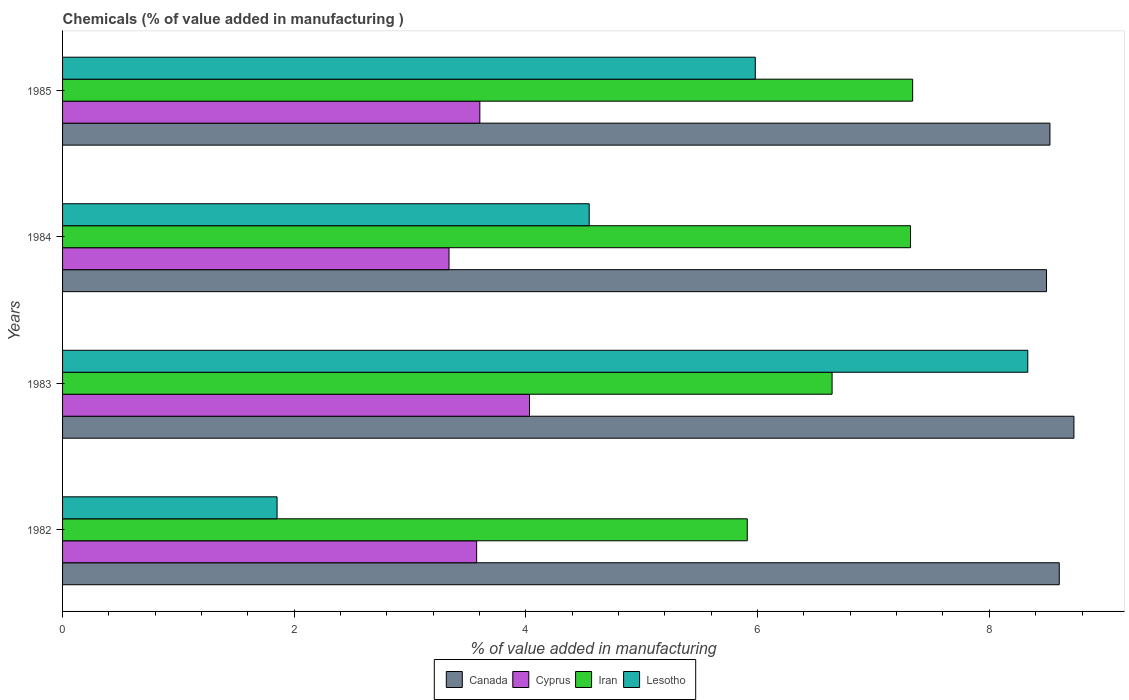How many groups of bars are there?
Your answer should be compact. 4. Are the number of bars per tick equal to the number of legend labels?
Offer a very short reply. Yes. How many bars are there on the 3rd tick from the top?
Make the answer very short. 4. In how many cases, is the number of bars for a given year not equal to the number of legend labels?
Your answer should be very brief. 0. What is the value added in manufacturing chemicals in Canada in 1984?
Ensure brevity in your answer.  8.49. Across all years, what is the maximum value added in manufacturing chemicals in Lesotho?
Provide a succinct answer. 8.33. Across all years, what is the minimum value added in manufacturing chemicals in Iran?
Your answer should be compact. 5.91. In which year was the value added in manufacturing chemicals in Iran minimum?
Offer a very short reply. 1982. What is the total value added in manufacturing chemicals in Lesotho in the graph?
Provide a short and direct response. 20.71. What is the difference between the value added in manufacturing chemicals in Lesotho in 1983 and that in 1985?
Give a very brief answer. 2.35. What is the difference between the value added in manufacturing chemicals in Canada in 1985 and the value added in manufacturing chemicals in Cyprus in 1982?
Provide a short and direct response. 4.95. What is the average value added in manufacturing chemicals in Iran per year?
Make the answer very short. 6.8. In the year 1984, what is the difference between the value added in manufacturing chemicals in Lesotho and value added in manufacturing chemicals in Canada?
Provide a succinct answer. -3.95. In how many years, is the value added in manufacturing chemicals in Canada greater than 6 %?
Offer a very short reply. 4. What is the ratio of the value added in manufacturing chemicals in Iran in 1983 to that in 1985?
Offer a very short reply. 0.91. Is the value added in manufacturing chemicals in Iran in 1984 less than that in 1985?
Keep it short and to the point. Yes. What is the difference between the highest and the second highest value added in manufacturing chemicals in Iran?
Make the answer very short. 0.02. What is the difference between the highest and the lowest value added in manufacturing chemicals in Iran?
Give a very brief answer. 1.43. In how many years, is the value added in manufacturing chemicals in Lesotho greater than the average value added in manufacturing chemicals in Lesotho taken over all years?
Offer a terse response. 2. Is the sum of the value added in manufacturing chemicals in Cyprus in 1982 and 1984 greater than the maximum value added in manufacturing chemicals in Iran across all years?
Your response must be concise. No. Is it the case that in every year, the sum of the value added in manufacturing chemicals in Canada and value added in manufacturing chemicals in Iran is greater than the sum of value added in manufacturing chemicals in Lesotho and value added in manufacturing chemicals in Cyprus?
Your response must be concise. No. What does the 4th bar from the top in 1984 represents?
Your answer should be compact. Canada. What does the 4th bar from the bottom in 1982 represents?
Ensure brevity in your answer.  Lesotho. How many bars are there?
Provide a short and direct response. 16. Are all the bars in the graph horizontal?
Offer a terse response. Yes. How many years are there in the graph?
Provide a succinct answer. 4. What is the difference between two consecutive major ticks on the X-axis?
Make the answer very short. 2. Does the graph contain any zero values?
Keep it short and to the point. No. How many legend labels are there?
Ensure brevity in your answer.  4. How are the legend labels stacked?
Ensure brevity in your answer.  Horizontal. What is the title of the graph?
Offer a very short reply. Chemicals (% of value added in manufacturing ). What is the label or title of the X-axis?
Offer a terse response. % of value added in manufacturing. What is the % of value added in manufacturing in Canada in 1982?
Make the answer very short. 8.6. What is the % of value added in manufacturing of Cyprus in 1982?
Your response must be concise. 3.57. What is the % of value added in manufacturing of Iran in 1982?
Offer a very short reply. 5.91. What is the % of value added in manufacturing of Lesotho in 1982?
Provide a short and direct response. 1.85. What is the % of value added in manufacturing in Canada in 1983?
Your answer should be very brief. 8.73. What is the % of value added in manufacturing of Cyprus in 1983?
Your answer should be compact. 4.03. What is the % of value added in manufacturing in Iran in 1983?
Your answer should be very brief. 6.64. What is the % of value added in manufacturing of Lesotho in 1983?
Make the answer very short. 8.33. What is the % of value added in manufacturing of Canada in 1984?
Make the answer very short. 8.49. What is the % of value added in manufacturing of Cyprus in 1984?
Provide a succinct answer. 3.34. What is the % of value added in manufacturing of Iran in 1984?
Your answer should be compact. 7.32. What is the % of value added in manufacturing of Lesotho in 1984?
Offer a terse response. 4.55. What is the % of value added in manufacturing of Canada in 1985?
Your answer should be compact. 8.52. What is the % of value added in manufacturing in Cyprus in 1985?
Provide a succinct answer. 3.6. What is the % of value added in manufacturing of Iran in 1985?
Ensure brevity in your answer.  7.34. What is the % of value added in manufacturing in Lesotho in 1985?
Your answer should be very brief. 5.98. Across all years, what is the maximum % of value added in manufacturing of Canada?
Provide a short and direct response. 8.73. Across all years, what is the maximum % of value added in manufacturing of Cyprus?
Offer a terse response. 4.03. Across all years, what is the maximum % of value added in manufacturing in Iran?
Your answer should be compact. 7.34. Across all years, what is the maximum % of value added in manufacturing in Lesotho?
Your answer should be compact. 8.33. Across all years, what is the minimum % of value added in manufacturing of Canada?
Offer a terse response. 8.49. Across all years, what is the minimum % of value added in manufacturing in Cyprus?
Provide a short and direct response. 3.34. Across all years, what is the minimum % of value added in manufacturing of Iran?
Give a very brief answer. 5.91. Across all years, what is the minimum % of value added in manufacturing of Lesotho?
Offer a terse response. 1.85. What is the total % of value added in manufacturing of Canada in the graph?
Your answer should be compact. 34.35. What is the total % of value added in manufacturing of Cyprus in the graph?
Provide a succinct answer. 14.54. What is the total % of value added in manufacturing in Iran in the graph?
Your answer should be compact. 27.21. What is the total % of value added in manufacturing of Lesotho in the graph?
Your answer should be very brief. 20.71. What is the difference between the % of value added in manufacturing of Canada in 1982 and that in 1983?
Provide a succinct answer. -0.13. What is the difference between the % of value added in manufacturing in Cyprus in 1982 and that in 1983?
Keep it short and to the point. -0.46. What is the difference between the % of value added in manufacturing of Iran in 1982 and that in 1983?
Provide a short and direct response. -0.73. What is the difference between the % of value added in manufacturing of Lesotho in 1982 and that in 1983?
Ensure brevity in your answer.  -6.48. What is the difference between the % of value added in manufacturing of Canada in 1982 and that in 1984?
Ensure brevity in your answer.  0.11. What is the difference between the % of value added in manufacturing in Cyprus in 1982 and that in 1984?
Give a very brief answer. 0.24. What is the difference between the % of value added in manufacturing in Iran in 1982 and that in 1984?
Give a very brief answer. -1.41. What is the difference between the % of value added in manufacturing of Lesotho in 1982 and that in 1984?
Your answer should be very brief. -2.69. What is the difference between the % of value added in manufacturing of Canada in 1982 and that in 1985?
Offer a very short reply. 0.08. What is the difference between the % of value added in manufacturing in Cyprus in 1982 and that in 1985?
Provide a succinct answer. -0.03. What is the difference between the % of value added in manufacturing of Iran in 1982 and that in 1985?
Make the answer very short. -1.43. What is the difference between the % of value added in manufacturing in Lesotho in 1982 and that in 1985?
Your answer should be very brief. -4.13. What is the difference between the % of value added in manufacturing of Canada in 1983 and that in 1984?
Give a very brief answer. 0.24. What is the difference between the % of value added in manufacturing of Cyprus in 1983 and that in 1984?
Ensure brevity in your answer.  0.69. What is the difference between the % of value added in manufacturing of Iran in 1983 and that in 1984?
Ensure brevity in your answer.  -0.68. What is the difference between the % of value added in manufacturing of Lesotho in 1983 and that in 1984?
Keep it short and to the point. 3.79. What is the difference between the % of value added in manufacturing in Canada in 1983 and that in 1985?
Offer a terse response. 0.21. What is the difference between the % of value added in manufacturing in Cyprus in 1983 and that in 1985?
Your answer should be compact. 0.43. What is the difference between the % of value added in manufacturing in Iran in 1983 and that in 1985?
Your answer should be compact. -0.7. What is the difference between the % of value added in manufacturing of Lesotho in 1983 and that in 1985?
Offer a very short reply. 2.35. What is the difference between the % of value added in manufacturing in Canada in 1984 and that in 1985?
Provide a short and direct response. -0.03. What is the difference between the % of value added in manufacturing of Cyprus in 1984 and that in 1985?
Provide a succinct answer. -0.27. What is the difference between the % of value added in manufacturing in Iran in 1984 and that in 1985?
Offer a terse response. -0.02. What is the difference between the % of value added in manufacturing in Lesotho in 1984 and that in 1985?
Provide a short and direct response. -1.43. What is the difference between the % of value added in manufacturing of Canada in 1982 and the % of value added in manufacturing of Cyprus in 1983?
Offer a very short reply. 4.57. What is the difference between the % of value added in manufacturing in Canada in 1982 and the % of value added in manufacturing in Iran in 1983?
Offer a terse response. 1.96. What is the difference between the % of value added in manufacturing in Canada in 1982 and the % of value added in manufacturing in Lesotho in 1983?
Your answer should be very brief. 0.27. What is the difference between the % of value added in manufacturing of Cyprus in 1982 and the % of value added in manufacturing of Iran in 1983?
Your response must be concise. -3.07. What is the difference between the % of value added in manufacturing of Cyprus in 1982 and the % of value added in manufacturing of Lesotho in 1983?
Ensure brevity in your answer.  -4.76. What is the difference between the % of value added in manufacturing of Iran in 1982 and the % of value added in manufacturing of Lesotho in 1983?
Your answer should be very brief. -2.42. What is the difference between the % of value added in manufacturing in Canada in 1982 and the % of value added in manufacturing in Cyprus in 1984?
Your answer should be very brief. 5.27. What is the difference between the % of value added in manufacturing of Canada in 1982 and the % of value added in manufacturing of Iran in 1984?
Provide a succinct answer. 1.28. What is the difference between the % of value added in manufacturing of Canada in 1982 and the % of value added in manufacturing of Lesotho in 1984?
Keep it short and to the point. 4.06. What is the difference between the % of value added in manufacturing of Cyprus in 1982 and the % of value added in manufacturing of Iran in 1984?
Make the answer very short. -3.75. What is the difference between the % of value added in manufacturing in Cyprus in 1982 and the % of value added in manufacturing in Lesotho in 1984?
Your answer should be compact. -0.97. What is the difference between the % of value added in manufacturing in Iran in 1982 and the % of value added in manufacturing in Lesotho in 1984?
Ensure brevity in your answer.  1.36. What is the difference between the % of value added in manufacturing in Canada in 1982 and the % of value added in manufacturing in Cyprus in 1985?
Provide a short and direct response. 5. What is the difference between the % of value added in manufacturing in Canada in 1982 and the % of value added in manufacturing in Iran in 1985?
Give a very brief answer. 1.27. What is the difference between the % of value added in manufacturing in Canada in 1982 and the % of value added in manufacturing in Lesotho in 1985?
Provide a succinct answer. 2.62. What is the difference between the % of value added in manufacturing in Cyprus in 1982 and the % of value added in manufacturing in Iran in 1985?
Offer a very short reply. -3.76. What is the difference between the % of value added in manufacturing in Cyprus in 1982 and the % of value added in manufacturing in Lesotho in 1985?
Your answer should be very brief. -2.41. What is the difference between the % of value added in manufacturing in Iran in 1982 and the % of value added in manufacturing in Lesotho in 1985?
Make the answer very short. -0.07. What is the difference between the % of value added in manufacturing in Canada in 1983 and the % of value added in manufacturing in Cyprus in 1984?
Your response must be concise. 5.39. What is the difference between the % of value added in manufacturing in Canada in 1983 and the % of value added in manufacturing in Iran in 1984?
Provide a succinct answer. 1.41. What is the difference between the % of value added in manufacturing in Canada in 1983 and the % of value added in manufacturing in Lesotho in 1984?
Your answer should be compact. 4.18. What is the difference between the % of value added in manufacturing in Cyprus in 1983 and the % of value added in manufacturing in Iran in 1984?
Keep it short and to the point. -3.29. What is the difference between the % of value added in manufacturing in Cyprus in 1983 and the % of value added in manufacturing in Lesotho in 1984?
Offer a terse response. -0.52. What is the difference between the % of value added in manufacturing of Iran in 1983 and the % of value added in manufacturing of Lesotho in 1984?
Make the answer very short. 2.1. What is the difference between the % of value added in manufacturing of Canada in 1983 and the % of value added in manufacturing of Cyprus in 1985?
Make the answer very short. 5.13. What is the difference between the % of value added in manufacturing in Canada in 1983 and the % of value added in manufacturing in Iran in 1985?
Your answer should be compact. 1.39. What is the difference between the % of value added in manufacturing of Canada in 1983 and the % of value added in manufacturing of Lesotho in 1985?
Ensure brevity in your answer.  2.75. What is the difference between the % of value added in manufacturing in Cyprus in 1983 and the % of value added in manufacturing in Iran in 1985?
Ensure brevity in your answer.  -3.31. What is the difference between the % of value added in manufacturing of Cyprus in 1983 and the % of value added in manufacturing of Lesotho in 1985?
Your answer should be very brief. -1.95. What is the difference between the % of value added in manufacturing of Iran in 1983 and the % of value added in manufacturing of Lesotho in 1985?
Your answer should be compact. 0.66. What is the difference between the % of value added in manufacturing in Canada in 1984 and the % of value added in manufacturing in Cyprus in 1985?
Make the answer very short. 4.89. What is the difference between the % of value added in manufacturing of Canada in 1984 and the % of value added in manufacturing of Iran in 1985?
Make the answer very short. 1.16. What is the difference between the % of value added in manufacturing of Canada in 1984 and the % of value added in manufacturing of Lesotho in 1985?
Give a very brief answer. 2.51. What is the difference between the % of value added in manufacturing in Cyprus in 1984 and the % of value added in manufacturing in Iran in 1985?
Give a very brief answer. -4. What is the difference between the % of value added in manufacturing of Cyprus in 1984 and the % of value added in manufacturing of Lesotho in 1985?
Provide a short and direct response. -2.64. What is the difference between the % of value added in manufacturing of Iran in 1984 and the % of value added in manufacturing of Lesotho in 1985?
Provide a short and direct response. 1.34. What is the average % of value added in manufacturing of Canada per year?
Provide a succinct answer. 8.59. What is the average % of value added in manufacturing in Cyprus per year?
Your answer should be very brief. 3.64. What is the average % of value added in manufacturing of Iran per year?
Your response must be concise. 6.8. What is the average % of value added in manufacturing of Lesotho per year?
Your answer should be very brief. 5.18. In the year 1982, what is the difference between the % of value added in manufacturing in Canada and % of value added in manufacturing in Cyprus?
Offer a very short reply. 5.03. In the year 1982, what is the difference between the % of value added in manufacturing of Canada and % of value added in manufacturing of Iran?
Give a very brief answer. 2.69. In the year 1982, what is the difference between the % of value added in manufacturing of Canada and % of value added in manufacturing of Lesotho?
Ensure brevity in your answer.  6.75. In the year 1982, what is the difference between the % of value added in manufacturing in Cyprus and % of value added in manufacturing in Iran?
Your response must be concise. -2.34. In the year 1982, what is the difference between the % of value added in manufacturing in Cyprus and % of value added in manufacturing in Lesotho?
Keep it short and to the point. 1.72. In the year 1982, what is the difference between the % of value added in manufacturing in Iran and % of value added in manufacturing in Lesotho?
Your answer should be very brief. 4.06. In the year 1983, what is the difference between the % of value added in manufacturing in Canada and % of value added in manufacturing in Cyprus?
Offer a very short reply. 4.7. In the year 1983, what is the difference between the % of value added in manufacturing in Canada and % of value added in manufacturing in Iran?
Offer a very short reply. 2.09. In the year 1983, what is the difference between the % of value added in manufacturing of Canada and % of value added in manufacturing of Lesotho?
Provide a short and direct response. 0.4. In the year 1983, what is the difference between the % of value added in manufacturing of Cyprus and % of value added in manufacturing of Iran?
Offer a very short reply. -2.61. In the year 1983, what is the difference between the % of value added in manufacturing in Cyprus and % of value added in manufacturing in Lesotho?
Give a very brief answer. -4.3. In the year 1983, what is the difference between the % of value added in manufacturing in Iran and % of value added in manufacturing in Lesotho?
Provide a succinct answer. -1.69. In the year 1984, what is the difference between the % of value added in manufacturing in Canada and % of value added in manufacturing in Cyprus?
Provide a succinct answer. 5.16. In the year 1984, what is the difference between the % of value added in manufacturing of Canada and % of value added in manufacturing of Iran?
Provide a short and direct response. 1.17. In the year 1984, what is the difference between the % of value added in manufacturing in Canada and % of value added in manufacturing in Lesotho?
Make the answer very short. 3.95. In the year 1984, what is the difference between the % of value added in manufacturing in Cyprus and % of value added in manufacturing in Iran?
Your response must be concise. -3.98. In the year 1984, what is the difference between the % of value added in manufacturing of Cyprus and % of value added in manufacturing of Lesotho?
Ensure brevity in your answer.  -1.21. In the year 1984, what is the difference between the % of value added in manufacturing in Iran and % of value added in manufacturing in Lesotho?
Keep it short and to the point. 2.77. In the year 1985, what is the difference between the % of value added in manufacturing of Canada and % of value added in manufacturing of Cyprus?
Keep it short and to the point. 4.92. In the year 1985, what is the difference between the % of value added in manufacturing in Canada and % of value added in manufacturing in Iran?
Your answer should be very brief. 1.19. In the year 1985, what is the difference between the % of value added in manufacturing of Canada and % of value added in manufacturing of Lesotho?
Give a very brief answer. 2.54. In the year 1985, what is the difference between the % of value added in manufacturing of Cyprus and % of value added in manufacturing of Iran?
Ensure brevity in your answer.  -3.74. In the year 1985, what is the difference between the % of value added in manufacturing in Cyprus and % of value added in manufacturing in Lesotho?
Keep it short and to the point. -2.38. In the year 1985, what is the difference between the % of value added in manufacturing in Iran and % of value added in manufacturing in Lesotho?
Your response must be concise. 1.36. What is the ratio of the % of value added in manufacturing of Canada in 1982 to that in 1983?
Provide a succinct answer. 0.99. What is the ratio of the % of value added in manufacturing of Cyprus in 1982 to that in 1983?
Your response must be concise. 0.89. What is the ratio of the % of value added in manufacturing of Iran in 1982 to that in 1983?
Keep it short and to the point. 0.89. What is the ratio of the % of value added in manufacturing of Lesotho in 1982 to that in 1983?
Offer a terse response. 0.22. What is the ratio of the % of value added in manufacturing of Cyprus in 1982 to that in 1984?
Provide a short and direct response. 1.07. What is the ratio of the % of value added in manufacturing in Iran in 1982 to that in 1984?
Your response must be concise. 0.81. What is the ratio of the % of value added in manufacturing of Lesotho in 1982 to that in 1984?
Your response must be concise. 0.41. What is the ratio of the % of value added in manufacturing of Canada in 1982 to that in 1985?
Provide a short and direct response. 1.01. What is the ratio of the % of value added in manufacturing in Cyprus in 1982 to that in 1985?
Give a very brief answer. 0.99. What is the ratio of the % of value added in manufacturing of Iran in 1982 to that in 1985?
Offer a very short reply. 0.81. What is the ratio of the % of value added in manufacturing of Lesotho in 1982 to that in 1985?
Offer a terse response. 0.31. What is the ratio of the % of value added in manufacturing in Canada in 1983 to that in 1984?
Offer a terse response. 1.03. What is the ratio of the % of value added in manufacturing of Cyprus in 1983 to that in 1984?
Ensure brevity in your answer.  1.21. What is the ratio of the % of value added in manufacturing of Iran in 1983 to that in 1984?
Make the answer very short. 0.91. What is the ratio of the % of value added in manufacturing in Lesotho in 1983 to that in 1984?
Provide a short and direct response. 1.83. What is the ratio of the % of value added in manufacturing of Canada in 1983 to that in 1985?
Provide a succinct answer. 1.02. What is the ratio of the % of value added in manufacturing in Cyprus in 1983 to that in 1985?
Offer a terse response. 1.12. What is the ratio of the % of value added in manufacturing of Iran in 1983 to that in 1985?
Make the answer very short. 0.91. What is the ratio of the % of value added in manufacturing of Lesotho in 1983 to that in 1985?
Provide a short and direct response. 1.39. What is the ratio of the % of value added in manufacturing in Cyprus in 1984 to that in 1985?
Offer a terse response. 0.93. What is the ratio of the % of value added in manufacturing of Iran in 1984 to that in 1985?
Your response must be concise. 1. What is the ratio of the % of value added in manufacturing in Lesotho in 1984 to that in 1985?
Offer a terse response. 0.76. What is the difference between the highest and the second highest % of value added in manufacturing of Canada?
Provide a succinct answer. 0.13. What is the difference between the highest and the second highest % of value added in manufacturing of Cyprus?
Your response must be concise. 0.43. What is the difference between the highest and the second highest % of value added in manufacturing of Iran?
Offer a very short reply. 0.02. What is the difference between the highest and the second highest % of value added in manufacturing of Lesotho?
Provide a short and direct response. 2.35. What is the difference between the highest and the lowest % of value added in manufacturing in Canada?
Your answer should be very brief. 0.24. What is the difference between the highest and the lowest % of value added in manufacturing of Cyprus?
Make the answer very short. 0.69. What is the difference between the highest and the lowest % of value added in manufacturing of Iran?
Offer a very short reply. 1.43. What is the difference between the highest and the lowest % of value added in manufacturing in Lesotho?
Offer a very short reply. 6.48. 